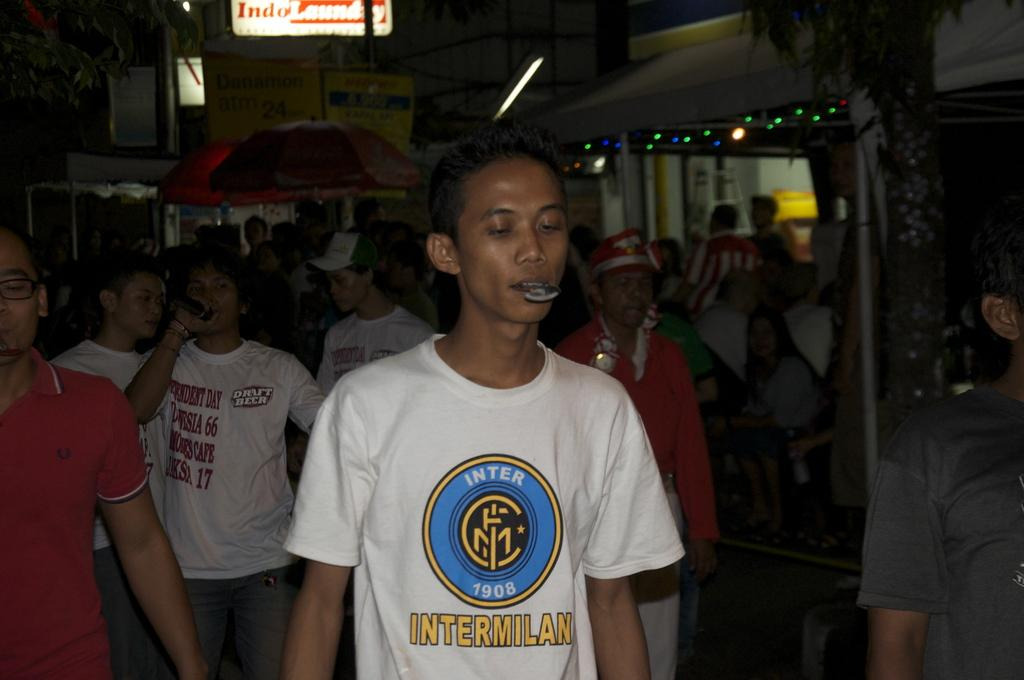What is the main subject of the image? The main subject of the image is a crowd of people. Can you describe the lighting conditions in the image? The image was clicked in the dark. What can be seen in the background of the image? There is a building and boards in the background of the image. What type of juice is being served to the horses in the image? There are no horses or juice present in the image. How many railway tracks can be seen in the image? There are no railway tracks visible in the image. 